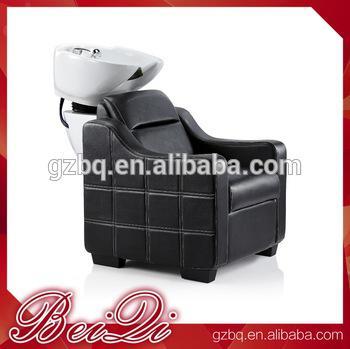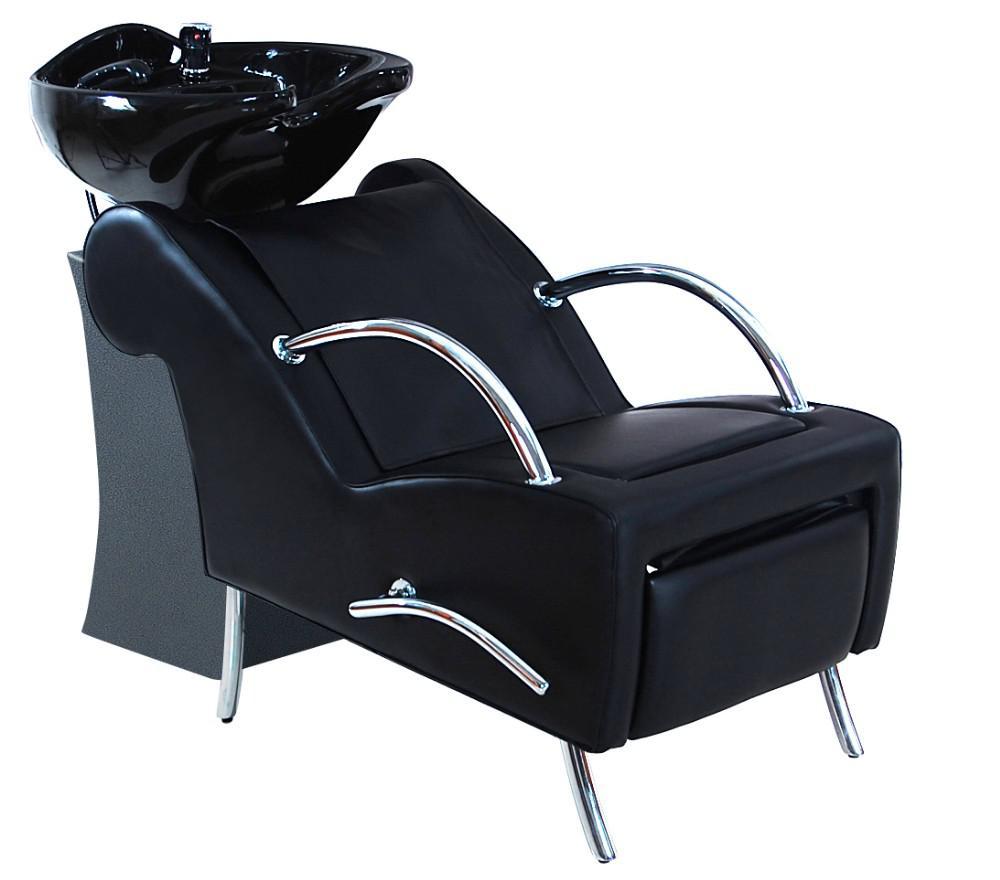The first image is the image on the left, the second image is the image on the right. For the images shown, is this caption "The right image features a reclined chair positioned under a small sink." true? Answer yes or no. Yes. The first image is the image on the left, the second image is the image on the right. For the images displayed, is the sentence "One of the images features two sinks." factually correct? Answer yes or no. No. 